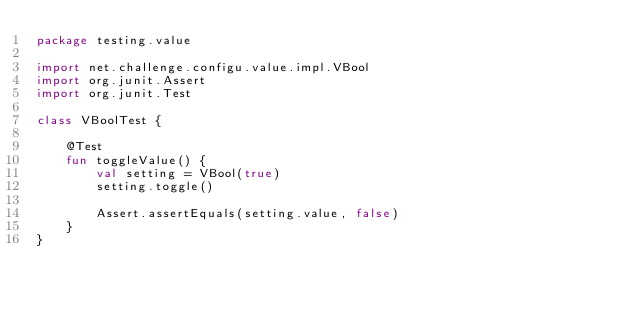Convert code to text. <code><loc_0><loc_0><loc_500><loc_500><_Kotlin_>package testing.value

import net.challenge.configu.value.impl.VBool
import org.junit.Assert
import org.junit.Test

class VBoolTest {

    @Test
    fun toggleValue() {
        val setting = VBool(true)
        setting.toggle()

        Assert.assertEquals(setting.value, false)
    }
}</code> 